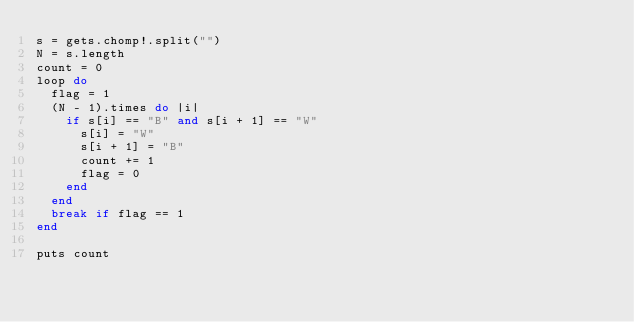Convert code to text. <code><loc_0><loc_0><loc_500><loc_500><_Ruby_>s = gets.chomp!.split("")
N = s.length
count = 0
loop do
  flag = 1
  (N - 1).times do |i|
    if s[i] == "B" and s[i + 1] == "W"
      s[i] = "W"
      s[i + 1] = "B"
      count += 1
      flag = 0
    end
  end
  break if flag == 1
end

puts count
</code> 